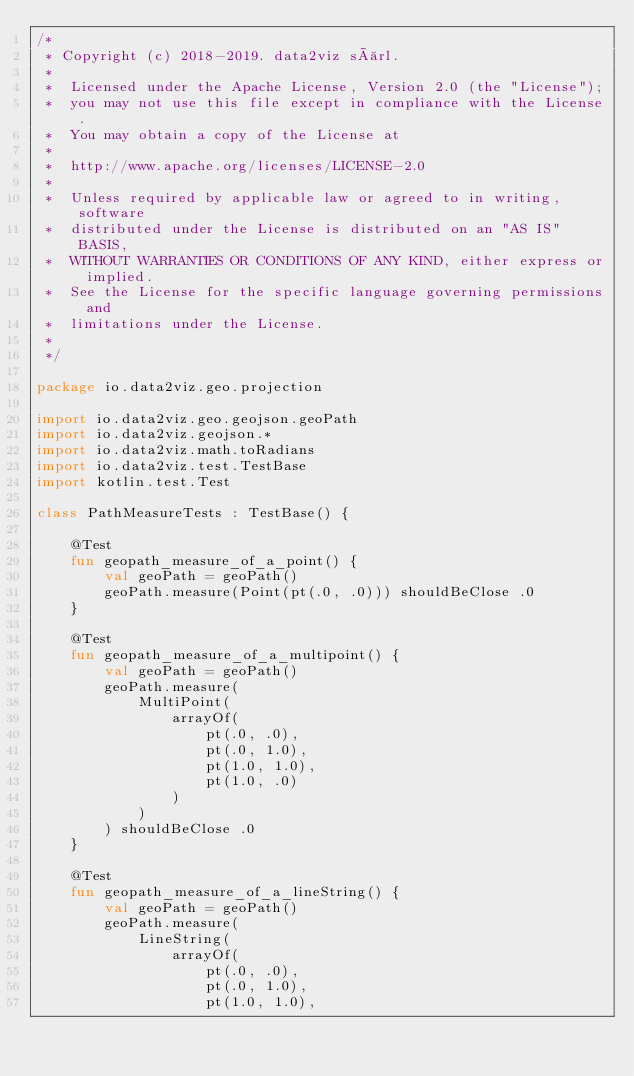<code> <loc_0><loc_0><loc_500><loc_500><_Kotlin_>/*
 * Copyright (c) 2018-2019. data2viz sàrl.
 *
 *  Licensed under the Apache License, Version 2.0 (the "License");
 *  you may not use this file except in compliance with the License.
 *  You may obtain a copy of the License at
 *
 *  http://www.apache.org/licenses/LICENSE-2.0
 *
 *  Unless required by applicable law or agreed to in writing, software
 *  distributed under the License is distributed on an "AS IS" BASIS,
 *  WITHOUT WARRANTIES OR CONDITIONS OF ANY KIND, either express or implied.
 *  See the License for the specific language governing permissions and
 *  limitations under the License.
 *
 */

package io.data2viz.geo.projection

import io.data2viz.geo.geojson.geoPath
import io.data2viz.geojson.*
import io.data2viz.math.toRadians
import io.data2viz.test.TestBase
import kotlin.test.Test

class PathMeasureTests : TestBase() {

    @Test
    fun geopath_measure_of_a_point() {
        val geoPath = geoPath()
        geoPath.measure(Point(pt(.0, .0))) shouldBeClose .0
    }

    @Test
    fun geopath_measure_of_a_multipoint() {
        val geoPath = geoPath()
        geoPath.measure(
            MultiPoint(
                arrayOf(
                    pt(.0, .0),
                    pt(.0, 1.0),
                    pt(1.0, 1.0),
                    pt(1.0, .0)
                )
            )
        ) shouldBeClose .0
    }

    @Test
    fun geopath_measure_of_a_lineString() {
        val geoPath = geoPath()
        geoPath.measure(
            LineString(
                arrayOf(
                    pt(.0, .0),
                    pt(.0, 1.0),
                    pt(1.0, 1.0),</code> 